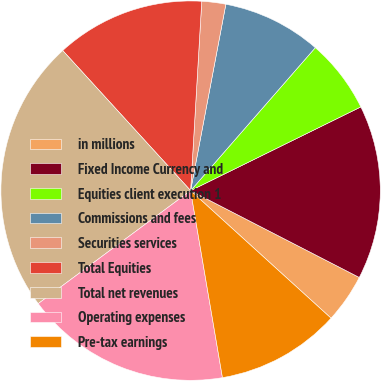Convert chart. <chart><loc_0><loc_0><loc_500><loc_500><pie_chart><fcel>in millions<fcel>Fixed Income Currency and<fcel>Equities client execution 1<fcel>Commissions and fees<fcel>Securities services<fcel>Total Equities<fcel>Total net revenues<fcel>Operating expenses<fcel>Pre-tax earnings<nl><fcel>4.17%<fcel>14.84%<fcel>6.31%<fcel>8.44%<fcel>2.04%<fcel>12.71%<fcel>23.38%<fcel>17.53%<fcel>10.58%<nl></chart> 